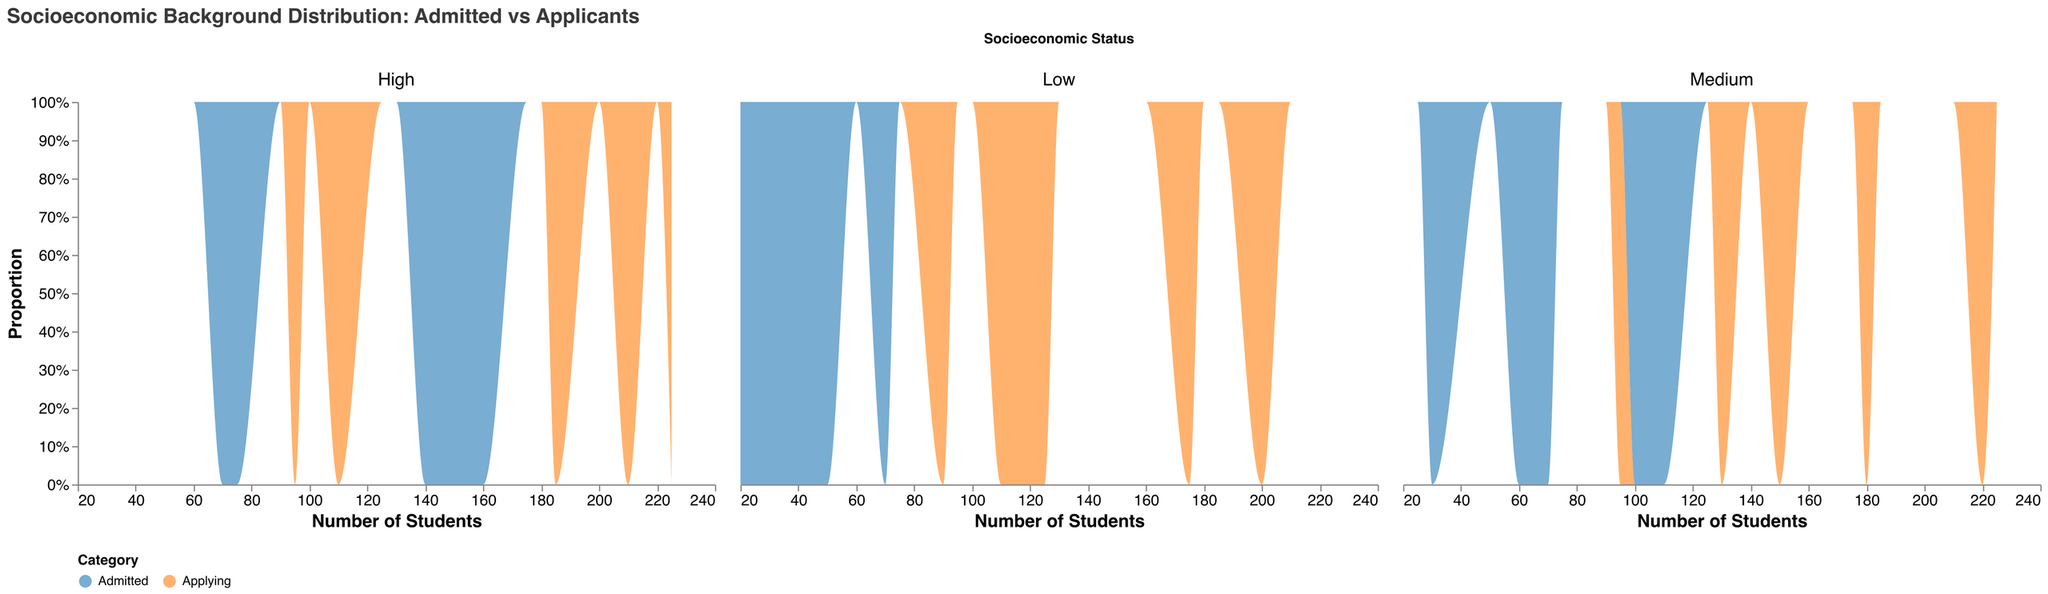What is the title of the plot? The title is located at the top of the plot and defines what the plot displays: "Socioeconomic Background Distribution: Admitted vs Applicants".
Answer: Socioeconomic Background Distribution: Admitted vs Applicants How many socioeconomic status groups are included in the plot? The plot has columns representing each group, labeled as "Low", "Medium", and "High".
Answer: Three What does each color represent in the plot? The legend at the bottom of the plot shows that one color represents "Applying" and the other color represents "Admitted".
Answer: Applying and Admitted Which socioeconomic status group has the highest proportion of admitted students? By examining the "High" socioeconomic status column, it is observed that the proportion of admitted students (area representing "Admitted") is larger compared to "Low" and "Medium" columns.
Answer: High How does the proportion of admitted students compare to the proportion of applicants in the "Medium" socioeconomic status? By looking at the "Medium" column, the "Admitted" area is larger than the "Applying" area, indicating a higher proportion of admitted students relative to the number of applicants.
Answer: Admitted proportion is higher What is the range of values on the x-axis? The x-axis is labeled "Number of Students" and ranges from the minimum to the maximum number of students applying or admitted. The exact values can be seen on the axis ticks.
Answer: 20 to 225 Which socioeconomic status group has the least number of total applicants? By comparing the columns of each socioeconomic status, the "Low" column shows lower applicant numbers than "Medium" and "High".
Answer: Low What is the approximate median number of admitted students in the "High" socioeconomic status? By analyzing the proportionate areas under "Admitted" in the "High" socioeconomic status column, the figures range from about 70 to 160. The median can be approximated as the middle value between the lower and upper bounds.
Answer: Approximately 140 Compare the density of applying students between "Low" and "High" socioeconomic statuses. The density plot in the "Low" column shows smaller counts at lower values, while the "High" column has higher counts spreading across a broader range of student numbers, indicating a higher density for the "High" socioeconomic status.
Answer: High has a higher density Explain how the area under each curve is used to represent proportions. The area under each curve is normalized to sum up to 100%, representing the proportion of students applying and admitted within each socioeconomic status. The height of the area in each segment visually indicates the proportion within that group.
Answer: Area represents proportions in each group 